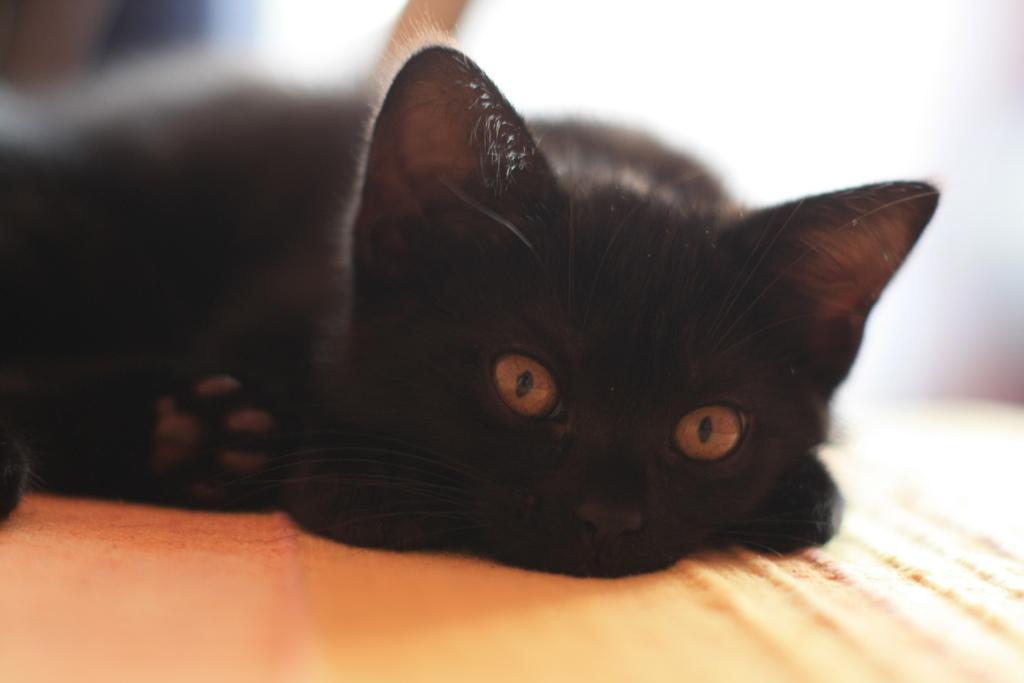Could you give a brief overview of what you see in this image? This picture contains a black cat. It is lying on the orange cloth. The cat is looking at the camera. In the background, it is blurred. 